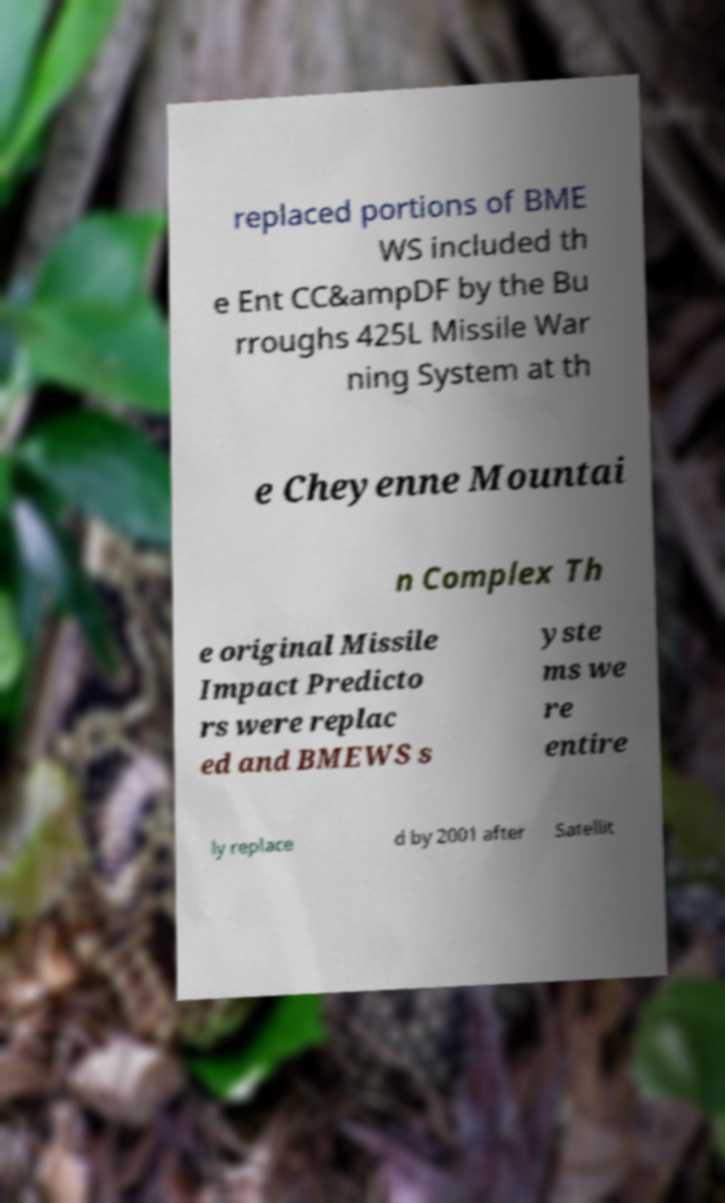I need the written content from this picture converted into text. Can you do that? replaced portions of BME WS included th e Ent CC&ampDF by the Bu rroughs 425L Missile War ning System at th e Cheyenne Mountai n Complex Th e original Missile Impact Predicto rs were replac ed and BMEWS s yste ms we re entire ly replace d by 2001 after Satellit 